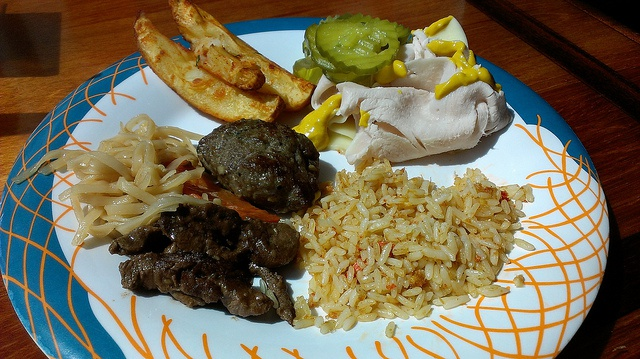Describe the objects in this image and their specific colors. I can see a dining table in black, maroon, tan, and lightblue tones in this image. 